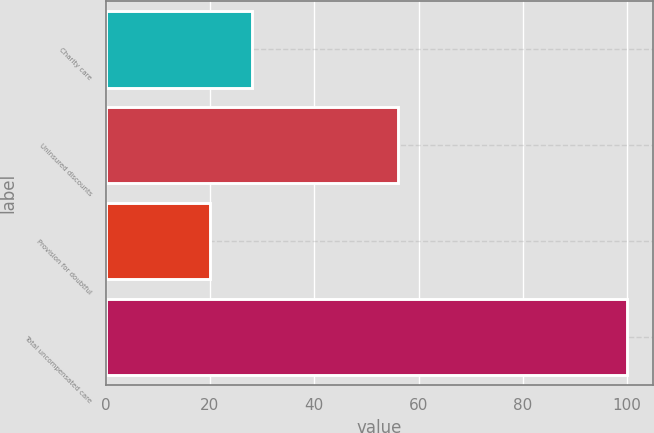Convert chart. <chart><loc_0><loc_0><loc_500><loc_500><bar_chart><fcel>Charity care<fcel>Uninsured discounts<fcel>Provision for doubtful<fcel>Total uncompensated care<nl><fcel>28<fcel>56<fcel>20<fcel>100<nl></chart> 